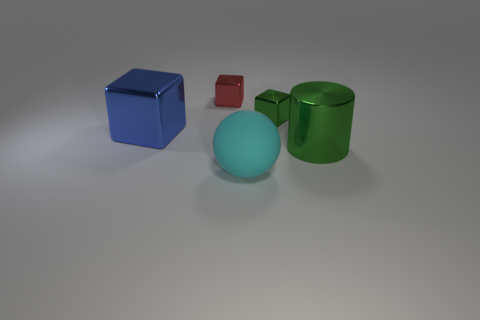Does the cube that is behind the tiny green metal thing have the same material as the green thing to the left of the cylinder?
Keep it short and to the point. Yes. How many other things are there of the same size as the cyan rubber object?
Give a very brief answer. 2. How many things are purple metallic cubes or large things that are behind the sphere?
Provide a short and direct response. 2. Is the number of big shiny cylinders on the left side of the red metallic cube the same as the number of red metallic things?
Your answer should be compact. No. There is a big thing that is the same material as the large cylinder; what shape is it?
Provide a succinct answer. Cube. Are there any other big blocks of the same color as the big shiny block?
Provide a succinct answer. No. What number of metal things are either small brown cylinders or large balls?
Your answer should be compact. 0. There is a tiny metal cube to the right of the large ball; what number of objects are right of it?
Keep it short and to the point. 1. Is the number of tiny metal cubes the same as the number of large red shiny things?
Keep it short and to the point. No. How many other tiny cubes have the same material as the small green cube?
Provide a succinct answer. 1. 